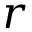Convert formula to latex. <formula><loc_0><loc_0><loc_500><loc_500>r</formula> 